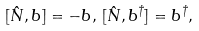<formula> <loc_0><loc_0><loc_500><loc_500>[ \hat { N } , b ] = - b , \, [ \hat { N } , b ^ { \dagger } ] = b ^ { \dagger } ,</formula> 